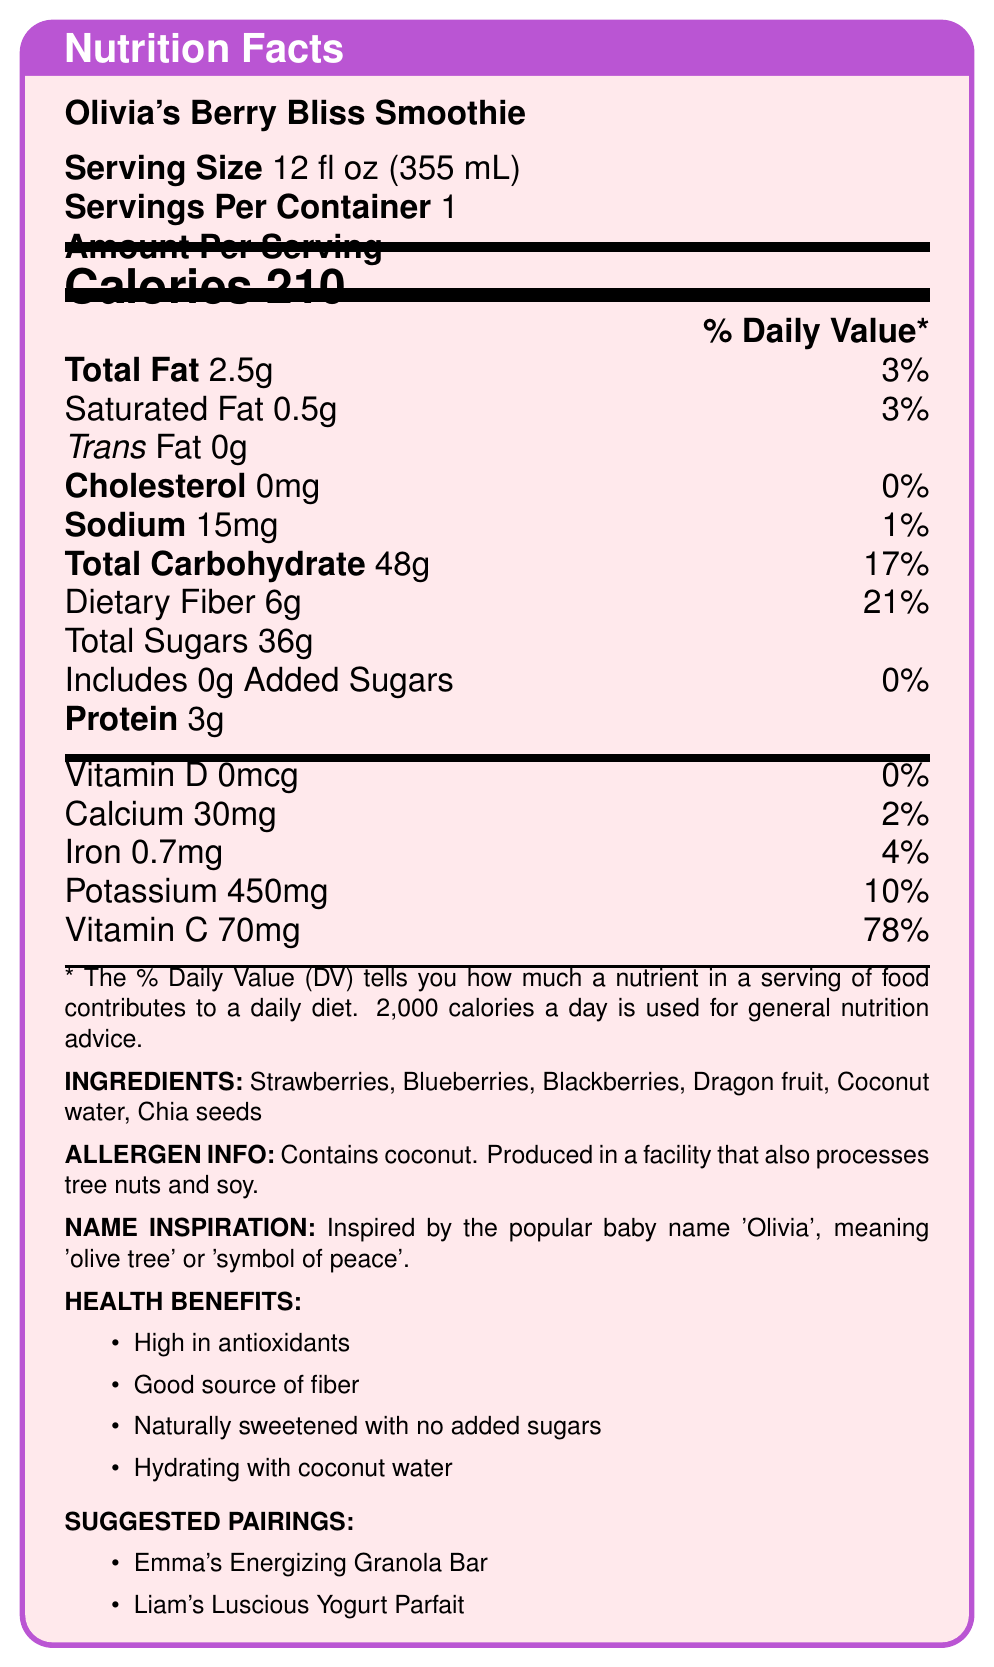what is the serving size? The document states that the serving size for Olivia's Berry Bliss Smoothie is 12 fl oz (355 mL).
Answer: 12 fl oz (355 mL) how many calories are in one serving? The document indicates that there are 210 calories in one serving of Olivia's Berry Bliss Smoothie.
Answer: 210 what is the amount of dietary fiber per serving? The document lists the dietary fiber content as 6g per serving, which also contributes to 21% of the daily value.
Answer: 6g does the smoothie contain any added sugars? According to the document, the smoothie contains 0g of added sugars.
Answer: No what are the main ingredients of the smoothie? The document provides a list of ingredients which includes Strawberries, Blueberries, Blackberries, Dragon fruit, Coconut water, and Chia seeds.
Answer: Strawberries, Blueberries, Blackberries, Dragon fruit, Coconut water, Chia seeds which vitamin has the highest percentage of the daily value in the smoothie? A. Vitamin D B. Calcium C. Iron D. Vitamin C According to the document, Vitamin C has the highest daily value percentage at 78%.
Answer: D what allergen information is provided? A. Contains milk B. Contains coconut C. Contains peanuts D. Contains gluten The allergen information states that the smoothie contains coconut and is produced in a facility that also processes tree nuts and soy.
Answer: B is the smoothie high in protein content? The document indicates that the smoothie contains 3g of protein, which is not considered high.
Answer: No does the smoothie contain any sodium? The document shows that the smoothie contains 15mg of sodium, which is 1% of the daily value.
Answer: Yes is the smoothie gluten-free? The document does not provide any specific information on whether the smoothie is gluten-free.
Answer: Not enough information summarize the main features of the smoothie This summary captures the nutritional content, ingredients, allergen information, inspiration for the name, health benefits, and suggested pairings of the smoothie as detailed in the document.
Answer: Olivia's Berry Bliss Smoothie is a 12 fl oz (355 mL) beverage containing 210 calories per serving. It is made from strawberries, blueberries, blackberries, dragon fruit, coconut water, and chia seeds. The smoothie has 2.5g of total fat, 2g of dietary fiber, and 36g of total sugars with no added sugars. It provides vitamins and minerals such as Calcium, Iron, Potassium, and Vitamin C. The allergen info specifies it contains coconut and is produced in a facility that processes tree nuts and soy. The inspiration for the name comes from 'Olivia', representing peace through a diverse and sweet fruit blend. Suggested pairings include Emma's Energizing Granola Bar and Liam's Luscious Yogurt Parfait. 